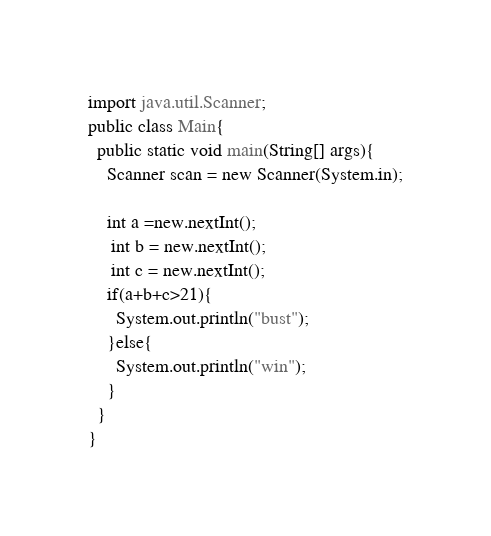<code> <loc_0><loc_0><loc_500><loc_500><_Java_>import java.util.Scanner;
public class Main{
  public static void main(String[] args){
    Scanner scan = new Scanner(System.in);
    
    int a =new.nextInt();
     int b = new.nextInt();
     int c = new.nextInt();
    if(a+b+c>21){
      System.out.println("bust");
    }else{
      System.out.println("win");
    }
  }
}</code> 